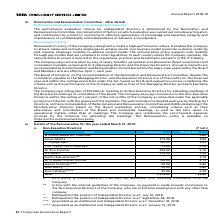According to Tata Consultancy Services's financial document, What is the sitting fee of Aman Mehta? According to the financial document, 4.80. The relevant text states: "andrasekaran, Chairman @ - 3.60 Aman Mehta 315.00 4.80 V Thyagarajan* 100.00 3.00 Prof Clayton M Christensen** 75.00 0.30 Dr Ron Sommer 220.00 5.10 O P Bh..." Also, What is the sitting fee of N Chandrasekaran? According to the financial document, 3.60. The relevant text states: "N Chandrasekaran, Chairman @ - 3.60 Aman Mehta 315.00 4.80 V Thyagarajan* 100.00 3.00 Prof Clayton M Christensen** 75.00 0.30 Dr Ron So..." Also, What is the sitting fee of O P Bhatt? According to the financial document, 7.50. The relevant text states: "0 0.30 Dr Ron Sommer 220.00 5.10 O P Bhatt 215.00 7.50 Aarthi Subramanian @@ - 5.70 Dr Pradeep Kumar Khosla 150.00 2.10 Hanne Sorensen*** 50.00 0.60 Keki..." Also, can you calculate: What is the difference in sitting fees between O P Bhatt and Aarthi Subramanian? Based on the calculation: 7.50-5.70, the result is 1.8. This is based on the information: ".10 O P Bhatt 215.00 7.50 Aarthi Subramanian @@ - 5.70 Dr Pradeep Kumar Khosla 150.00 2.10 Hanne Sorensen*** 50.00 0.60 Keki Mistry*** 50.00 0.60 Don Call 0 0.30 Dr Ron Sommer 220.00 5.10 O P Bhatt 21..." The key data points involved are: 5.70, 7.50. Also, can you calculate: What is the difference in commission between O P Bhatt and Dr Ron Sommer? Based on the calculation: 220.00-215.00, the result is 5. This is based on the information: "Clayton M Christensen** 75.00 0.30 Dr Ron Sommer 220.00 5.10 O P Bhatt 215.00 7.50 Aarthi Subramanian @@ - 5.70 Dr Pradeep Kumar Khosla 150.00 2.10 Hanne S ** 75.00 0.30 Dr Ron Sommer 220.00 5.10 O P ..." The key data points involved are: 215.00, 220.00. Additionally, Which non-executive director had the highest sitting fees? According to the financial document, O P Bhatt. The relevant text states: "hristensen** 75.00 0.30 Dr Ron Sommer 220.00 5.10 O P Bhatt 215.00 7.50 Aarthi Subramanian @@ - 5.70 Dr Pradeep Kumar Khosla 150.00 2.10 Hanne Sorensen*** 50.0..." 